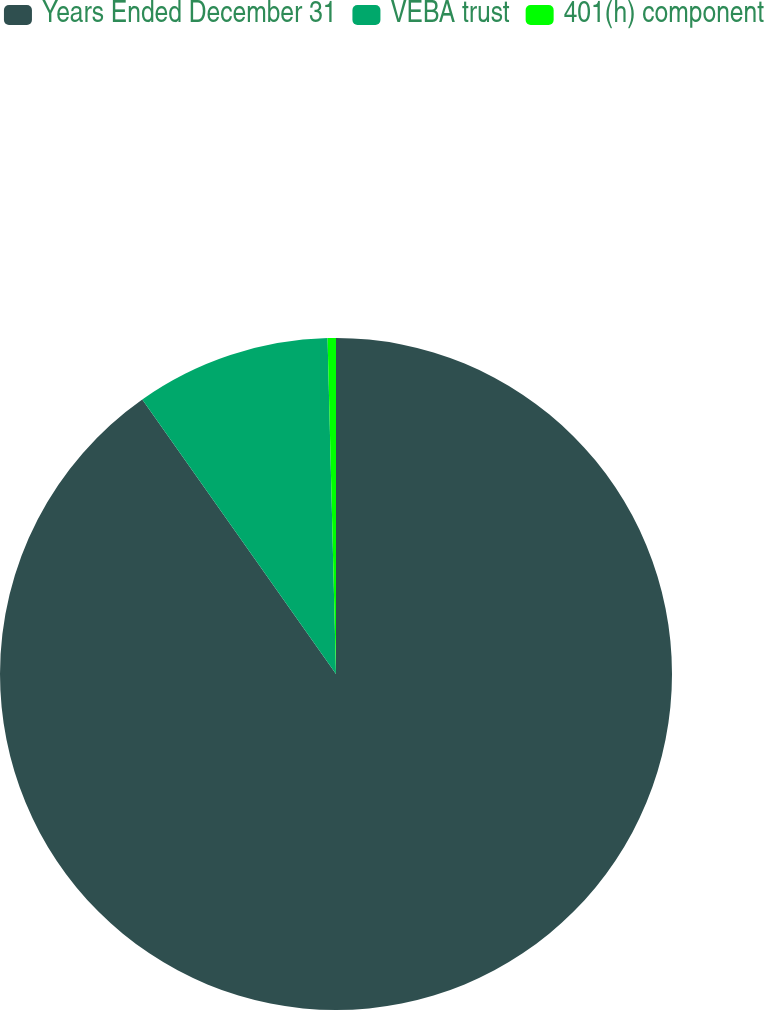Convert chart to OTSL. <chart><loc_0><loc_0><loc_500><loc_500><pie_chart><fcel>Years Ended December 31<fcel>VEBA trust<fcel>401(h) component<nl><fcel>90.21%<fcel>9.38%<fcel>0.4%<nl></chart> 